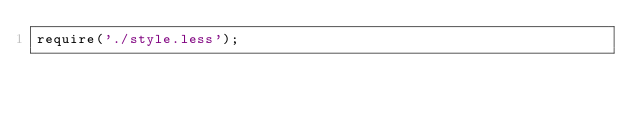Convert code to text. <code><loc_0><loc_0><loc_500><loc_500><_JavaScript_>require('./style.less');</code> 